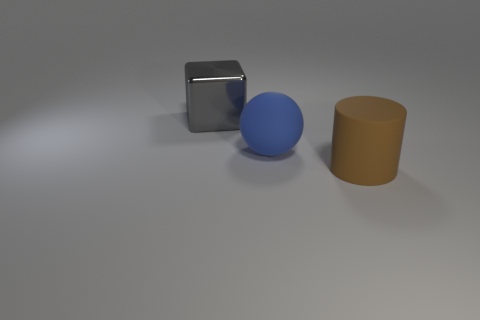Subtract all cylinders. How many objects are left? 2 Add 1 brown rubber cylinders. How many brown rubber cylinders exist? 2 Add 2 big rubber cylinders. How many objects exist? 5 Subtract 0 green blocks. How many objects are left? 3 Subtract 1 cylinders. How many cylinders are left? 0 Subtract all yellow cubes. Subtract all brown cylinders. How many cubes are left? 1 Subtract all green cubes. How many cyan cylinders are left? 0 Subtract all big cylinders. Subtract all gray rubber objects. How many objects are left? 2 Add 2 metal objects. How many metal objects are left? 3 